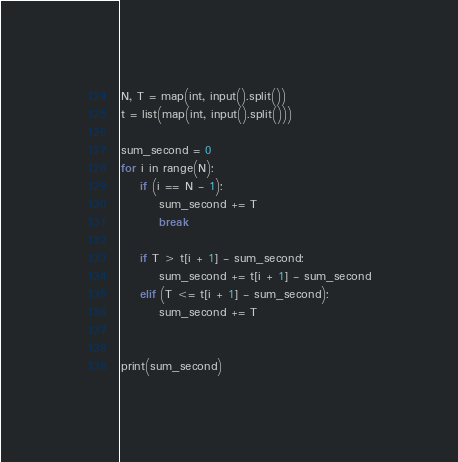Convert code to text. <code><loc_0><loc_0><loc_500><loc_500><_Python_>N, T = map(int, input().split())
t = list(map(int, input().split()))

sum_second = 0
for i in range(N):
    if (i == N - 1):
        sum_second += T
        break

    if T > t[i + 1] - sum_second:
        sum_second += t[i + 1] - sum_second
    elif (T <= t[i + 1] - sum_second):
        sum_second += T


print(sum_second)
</code> 